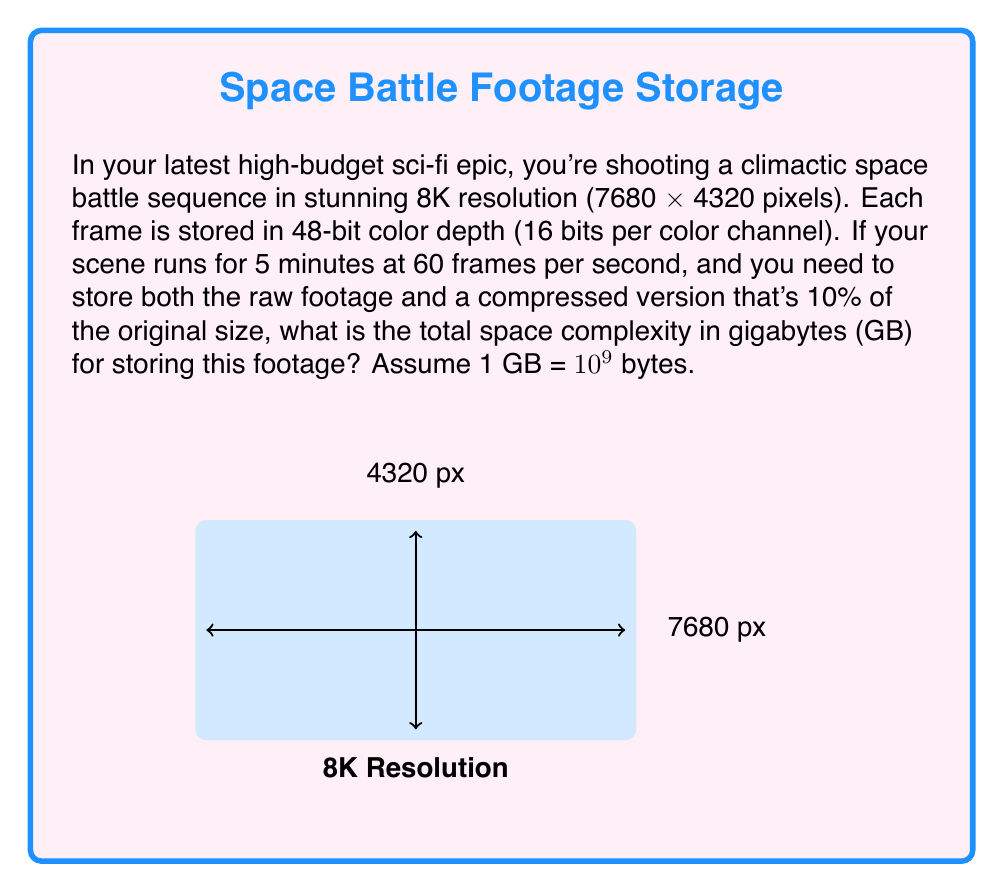What is the answer to this math problem? Let's break this down step-by-step:

1) First, calculate the number of pixels in each frame:
   $7680 \times 4320 = 33,177,600$ pixels

2) Each pixel uses 48 bits (16 bits × 3 color channels):
   $33,177,600 \times 48 = 1,592,524,800$ bits per frame

3) Convert bits to bytes:
   $1,592,524,800 \div 8 = 199,065,600$ bytes per frame

4) Calculate the number of frames in 5 minutes:
   $5 \times 60 \times 60 = 18,000$ frames

5) Total raw data size:
   $199,065,600 \times 18,000 = 3,583,180,800,000$ bytes

6) Convert to GB:
   $3,583,180,800,000 \div 10^9 \approx 3,583.18$ GB

7) Compressed version (10% of original):
   $3,583.18 \times 0.1 \approx 358.32$ GB

8) Total space needed (raw + compressed):
   $3,583.18 + 358.32 = 3,941.50$ GB

Therefore, the total space complexity for storing both the raw and compressed footage is approximately 3,941.50 GB.
Answer: $$3,941.50 \text{ GB}$$ 